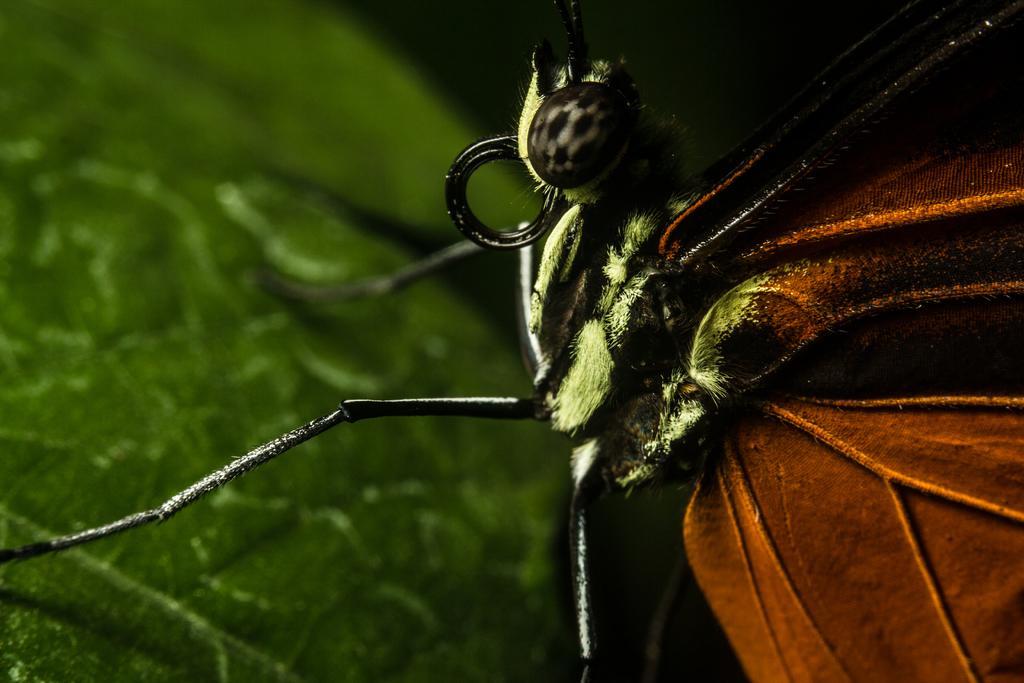Can you describe this image briefly? In this picture it looks like the upper body of an insect on a green leaf. 